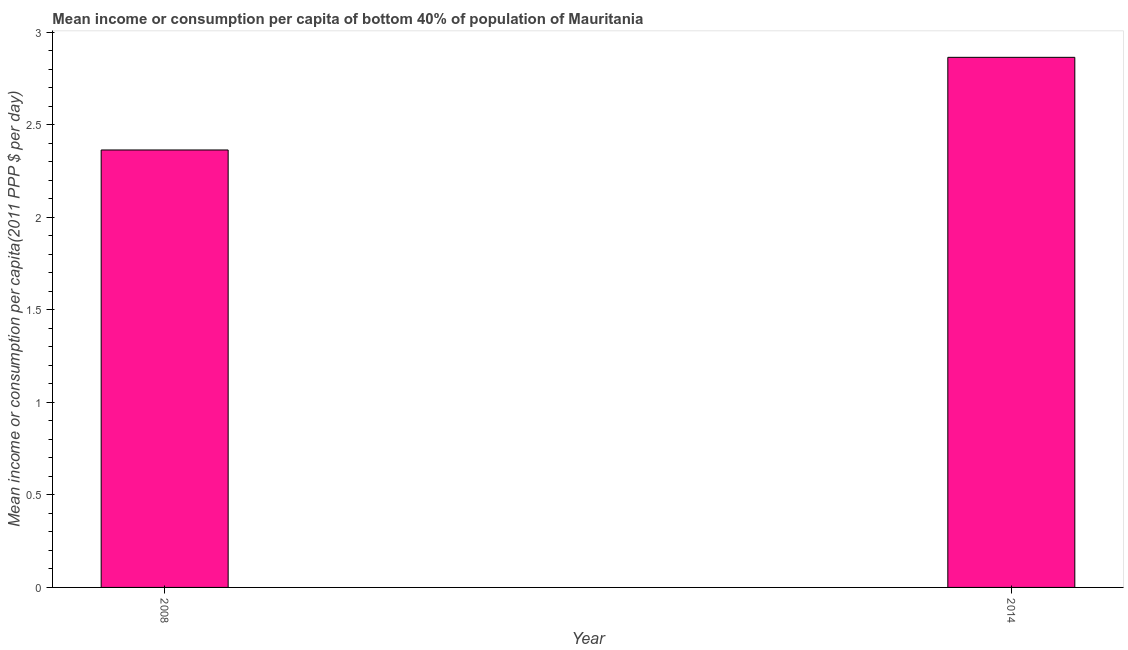Does the graph contain any zero values?
Offer a terse response. No. What is the title of the graph?
Your response must be concise. Mean income or consumption per capita of bottom 40% of population of Mauritania. What is the label or title of the X-axis?
Offer a terse response. Year. What is the label or title of the Y-axis?
Provide a short and direct response. Mean income or consumption per capita(2011 PPP $ per day). What is the mean income or consumption in 2014?
Your answer should be very brief. 2.86. Across all years, what is the maximum mean income or consumption?
Give a very brief answer. 2.86. Across all years, what is the minimum mean income or consumption?
Your response must be concise. 2.36. In which year was the mean income or consumption maximum?
Your answer should be compact. 2014. In which year was the mean income or consumption minimum?
Ensure brevity in your answer.  2008. What is the sum of the mean income or consumption?
Ensure brevity in your answer.  5.23. What is the average mean income or consumption per year?
Offer a very short reply. 2.61. What is the median mean income or consumption?
Offer a very short reply. 2.61. In how many years, is the mean income or consumption greater than 2.6 $?
Keep it short and to the point. 1. What is the ratio of the mean income or consumption in 2008 to that in 2014?
Offer a very short reply. 0.82. In how many years, is the mean income or consumption greater than the average mean income or consumption taken over all years?
Give a very brief answer. 1. What is the difference between two consecutive major ticks on the Y-axis?
Provide a short and direct response. 0.5. What is the Mean income or consumption per capita(2011 PPP $ per day) in 2008?
Give a very brief answer. 2.36. What is the Mean income or consumption per capita(2011 PPP $ per day) of 2014?
Make the answer very short. 2.86. What is the difference between the Mean income or consumption per capita(2011 PPP $ per day) in 2008 and 2014?
Your answer should be compact. -0.5. What is the ratio of the Mean income or consumption per capita(2011 PPP $ per day) in 2008 to that in 2014?
Give a very brief answer. 0.82. 